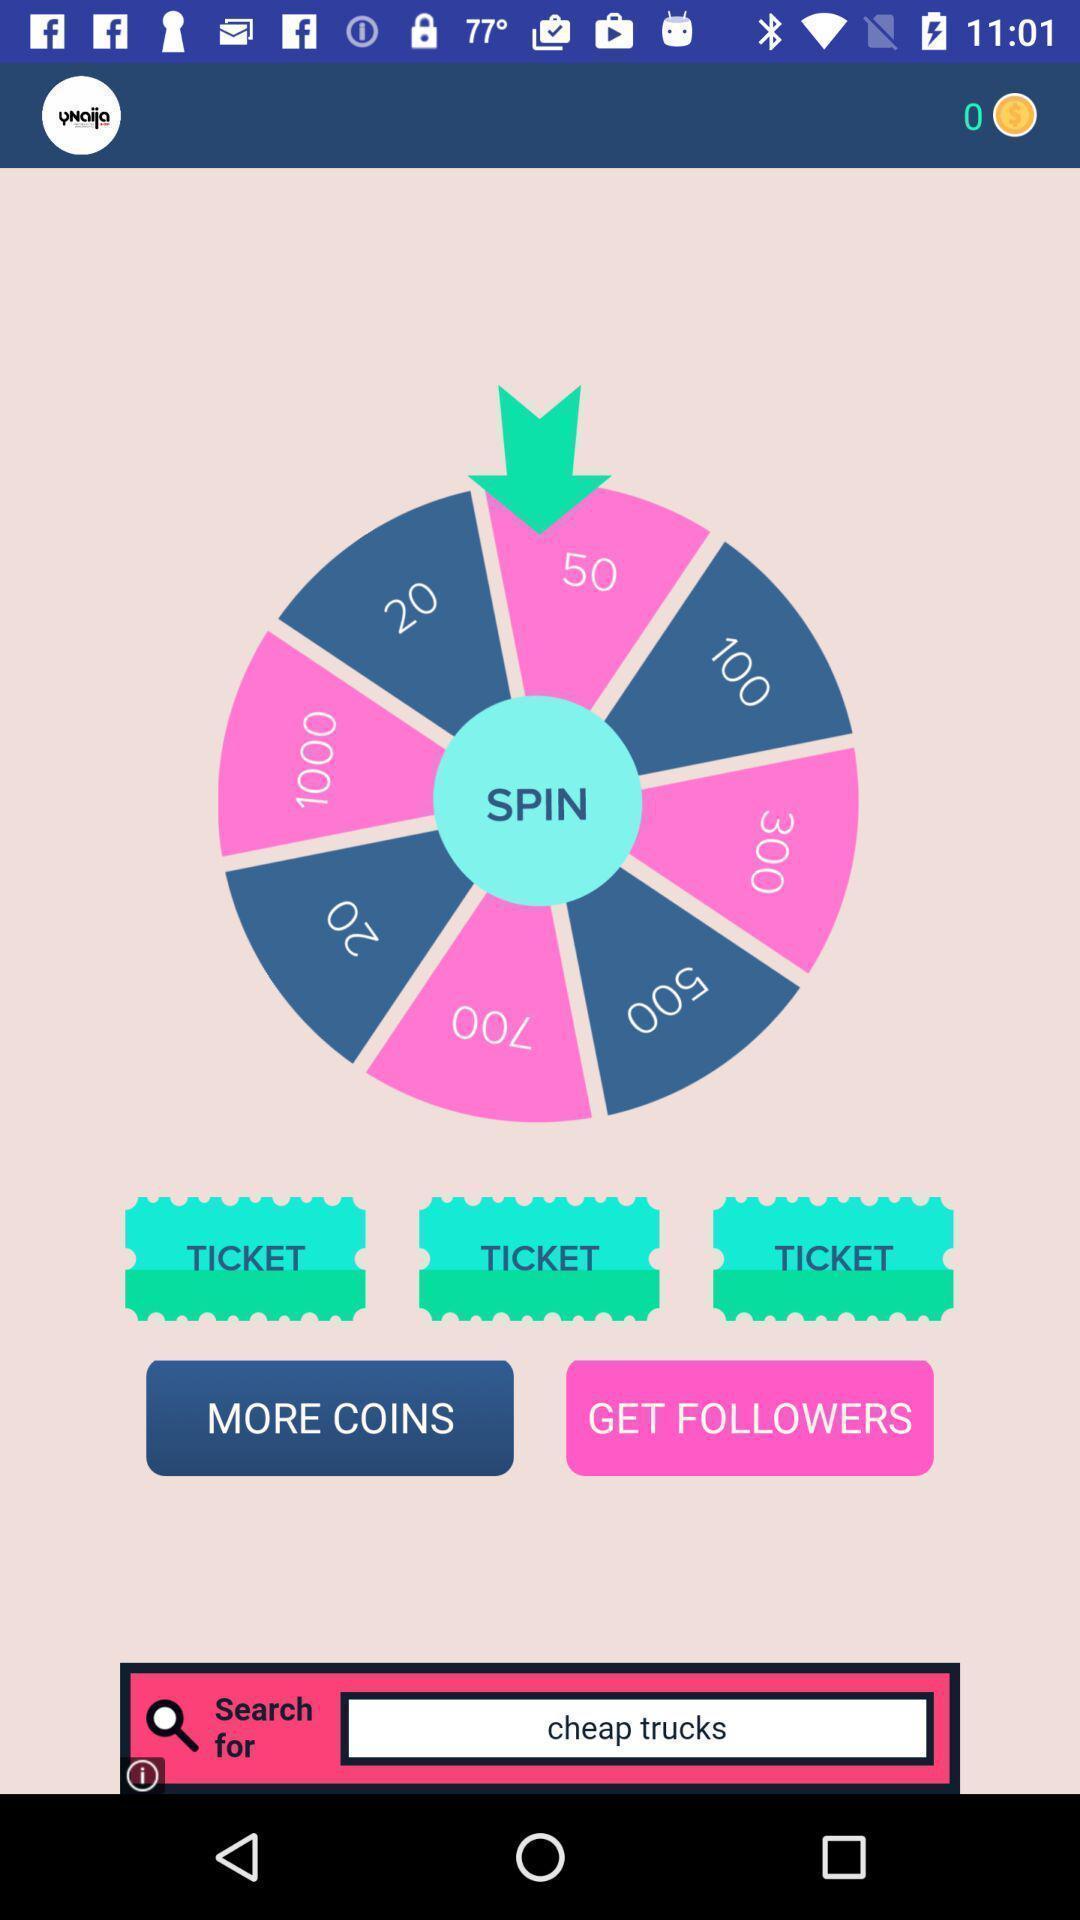Please provide a description for this image. Page showing the spin wheel with multiple options. 